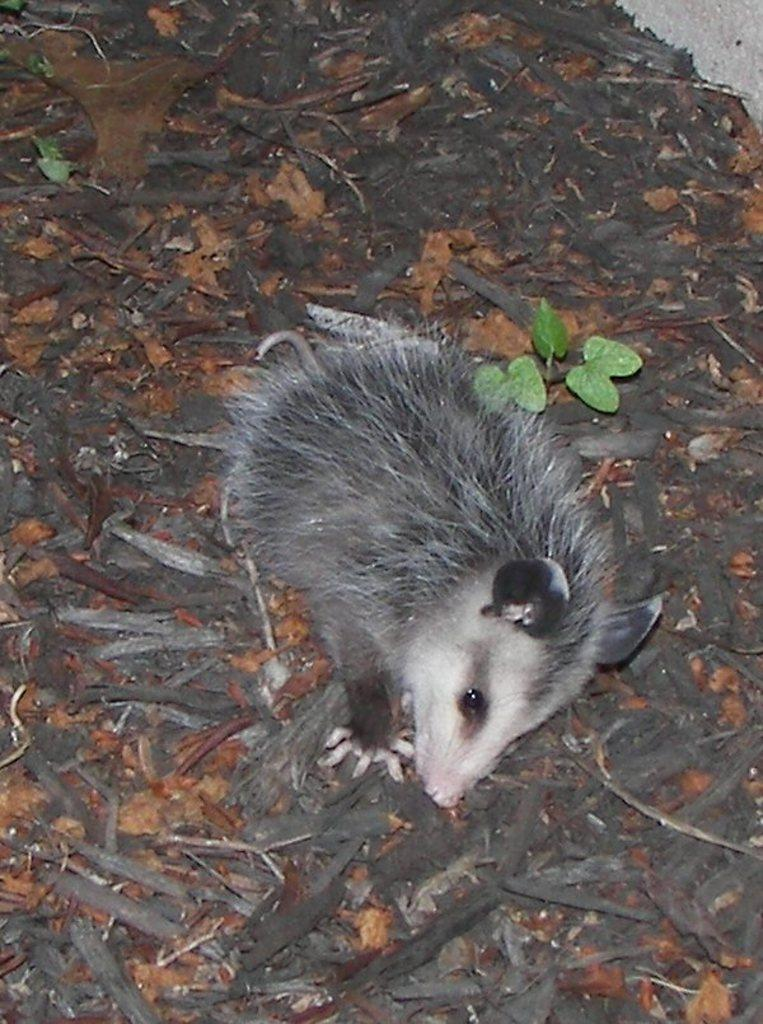What type of animal is in the image? There is an animal in the image, but we cannot determine its specific type from the provided facts. What can be seen in the background of the image? There are leaves in the image. What material are the pieces on the land made of? The wooden pieces on the land in the image are made of wood. What degree does the laborer have in the image? There is no laborer or degree present in the image. How many seats can be seen in the image? There are no seats visible in the image. 